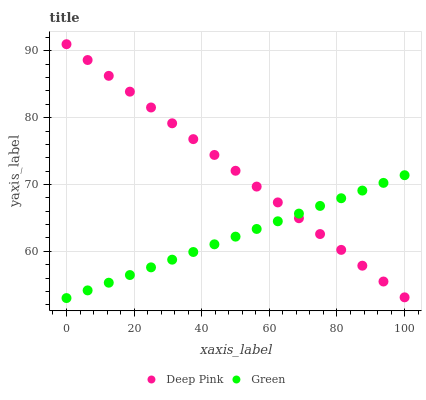Does Green have the minimum area under the curve?
Answer yes or no. Yes. Does Deep Pink have the maximum area under the curve?
Answer yes or no. Yes. Does Green have the maximum area under the curve?
Answer yes or no. No. Is Green the smoothest?
Answer yes or no. Yes. Is Deep Pink the roughest?
Answer yes or no. Yes. Is Green the roughest?
Answer yes or no. No. Does Green have the lowest value?
Answer yes or no. Yes. Does Deep Pink have the highest value?
Answer yes or no. Yes. Does Green have the highest value?
Answer yes or no. No. Does Green intersect Deep Pink?
Answer yes or no. Yes. Is Green less than Deep Pink?
Answer yes or no. No. Is Green greater than Deep Pink?
Answer yes or no. No. 